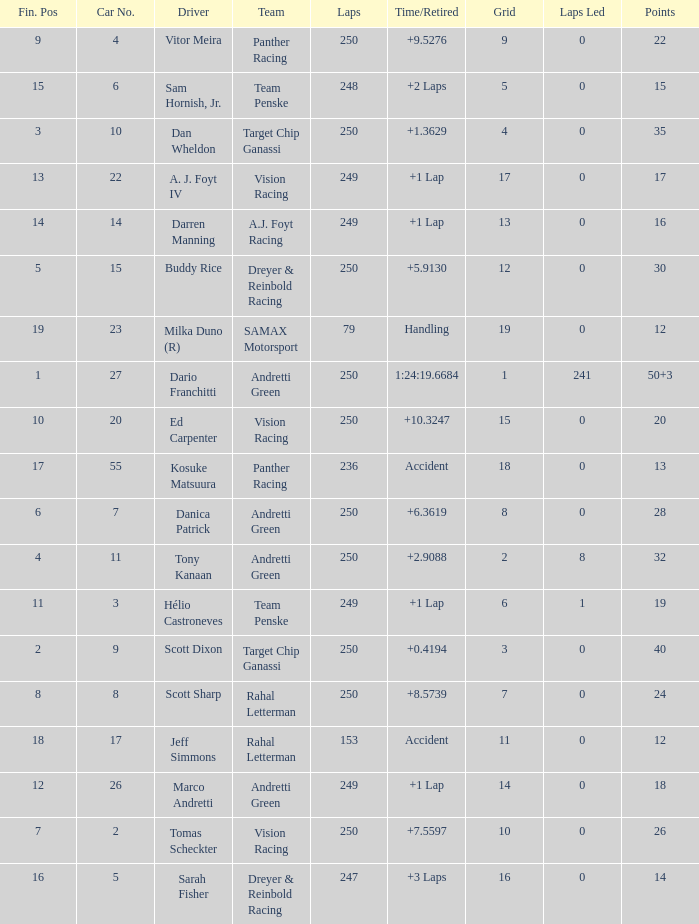Name the least grid for 17 points  17.0. 